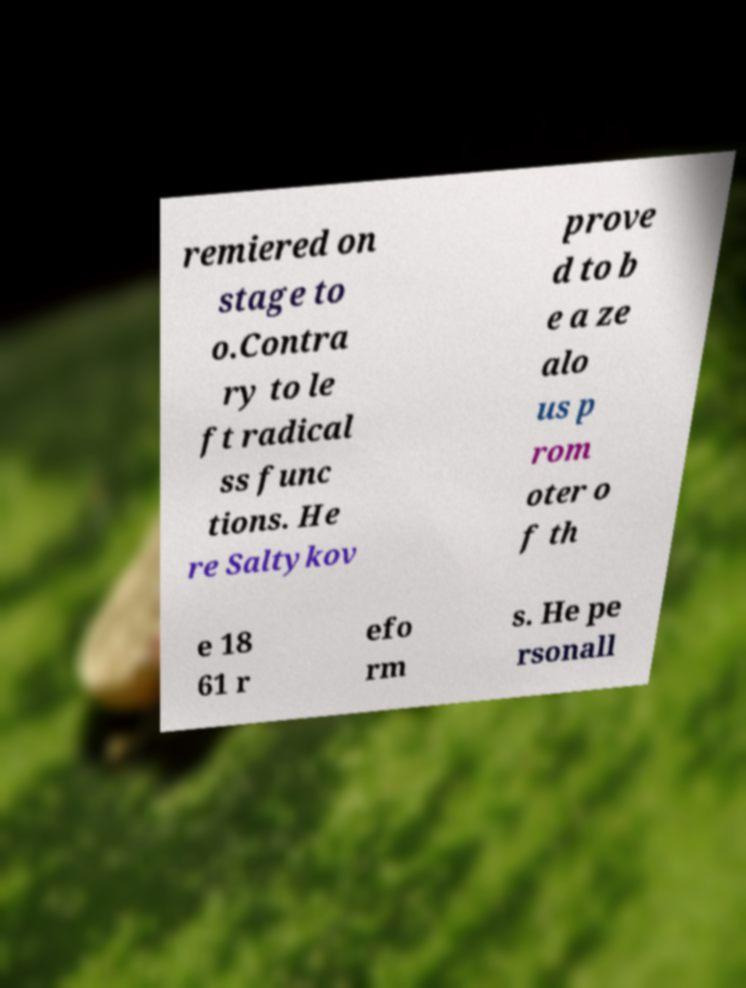Please read and relay the text visible in this image. What does it say? remiered on stage to o.Contra ry to le ft radical ss func tions. He re Saltykov prove d to b e a ze alo us p rom oter o f th e 18 61 r efo rm s. He pe rsonall 